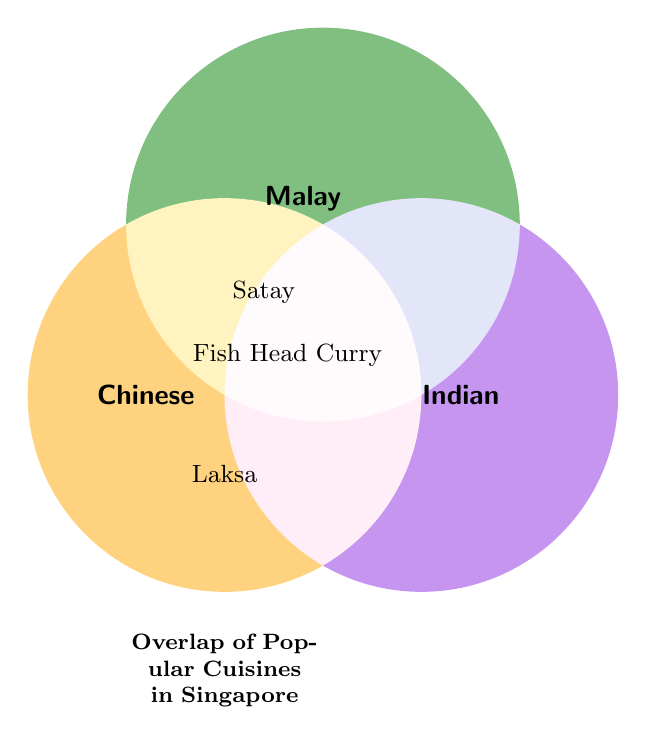What cuisines are listed in the title? The title of the diagram is "Overlap of Popular Cuisines in Singapore" which indicates three cuisines: Chinese, Malay, and Indian.
Answer: Chinese, Malay, Indian Which dishes are shared between Chinese and Indian cuisines? By viewing the areas overlapping between the Chinese and Indian circles, "Fish Head Curry" is the dish shared between them.
Answer: Fish Head Curry Is Satay shared by all three cuisines? Satay is located in the overlapping area of the Chinese and Malay circles but outside the Indian circle, indicating it is not shared by all three.
Answer: No Which dishes are shared by Chinese and Malay cuisines but not by Indian cuisine? By looking at the overlapping area of Chinese and Malay but outside Indian, "Laksa" and "Satay" are the dishes shared by these two but not by Indian cuisine.
Answer: Laksa, Satay What dish is unique to the area where only Malay and Indian overlap? There are no dishes identified in the region where only Malay and Indian overlap.
Answer: None Which cuisine does not have any unique dishes listed? Since no dish is placed solely within one single circle for any cuisine, all cuisines are shared in combination with others, indicating that no unique dishes are listed for any single cuisine.
Answer: All How many dishes are shared between Chinese and Malay cuisines? By identifying the dishes in the overlapping regions of Chinese and Malay, we see "Laksa" and "Satay".
Answer: Two Which dish is found in the overlapping region of all three cuisines? Examining the central area where all three circles intersect shows that there is no dish placed in this region, indicating no common dish among all three.
Answer: None Which dish is in the overlapping region of Chinese and Malay but outside Indian? "Satay" is located in the overlapping region between Chinese and Malay but outside the Indian circle. Laksa is also there but asked in another question.
Answer: Satay Is Fish Head Curry unique to just one cuisine? Fish Head Curry is in the overlapping area between Chinese and Indian, so it is not unique to just one cuisine.
Answer: No 